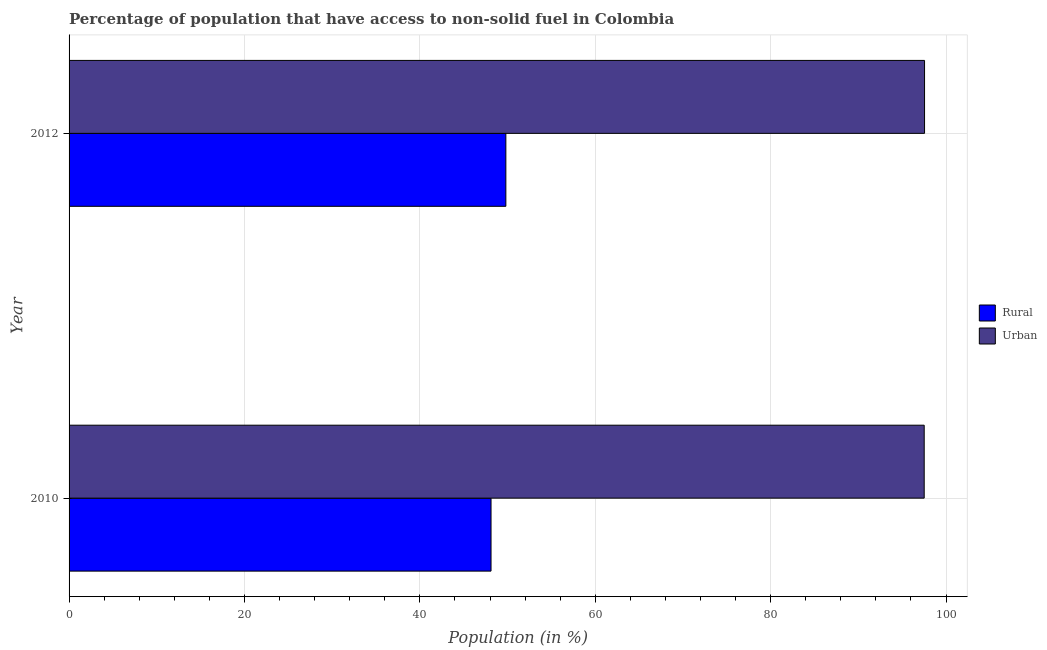How many different coloured bars are there?
Ensure brevity in your answer.  2. Are the number of bars per tick equal to the number of legend labels?
Offer a very short reply. Yes. How many bars are there on the 1st tick from the top?
Offer a terse response. 2. How many bars are there on the 2nd tick from the bottom?
Provide a succinct answer. 2. In how many cases, is the number of bars for a given year not equal to the number of legend labels?
Make the answer very short. 0. What is the urban population in 2010?
Offer a terse response. 97.51. Across all years, what is the maximum rural population?
Offer a very short reply. 49.81. Across all years, what is the minimum rural population?
Your answer should be compact. 48.11. In which year was the urban population minimum?
Provide a short and direct response. 2010. What is the total urban population in the graph?
Give a very brief answer. 195.06. What is the difference between the rural population in 2010 and that in 2012?
Your answer should be compact. -1.69. What is the difference between the rural population in 2010 and the urban population in 2012?
Ensure brevity in your answer.  -49.43. What is the average urban population per year?
Make the answer very short. 97.53. In the year 2012, what is the difference between the urban population and rural population?
Offer a terse response. 47.74. What is the ratio of the rural population in 2010 to that in 2012?
Ensure brevity in your answer.  0.97. In how many years, is the urban population greater than the average urban population taken over all years?
Your answer should be compact. 1. What does the 2nd bar from the top in 2010 represents?
Ensure brevity in your answer.  Rural. What does the 1st bar from the bottom in 2010 represents?
Make the answer very short. Rural. How many bars are there?
Ensure brevity in your answer.  4. Are all the bars in the graph horizontal?
Ensure brevity in your answer.  Yes. How many legend labels are there?
Your response must be concise. 2. How are the legend labels stacked?
Your response must be concise. Vertical. What is the title of the graph?
Ensure brevity in your answer.  Percentage of population that have access to non-solid fuel in Colombia. Does "Under-five" appear as one of the legend labels in the graph?
Offer a very short reply. No. What is the Population (in %) of Rural in 2010?
Provide a succinct answer. 48.11. What is the Population (in %) of Urban in 2010?
Ensure brevity in your answer.  97.51. What is the Population (in %) of Rural in 2012?
Your answer should be very brief. 49.81. What is the Population (in %) in Urban in 2012?
Provide a short and direct response. 97.55. Across all years, what is the maximum Population (in %) of Rural?
Provide a short and direct response. 49.81. Across all years, what is the maximum Population (in %) of Urban?
Your response must be concise. 97.55. Across all years, what is the minimum Population (in %) of Rural?
Make the answer very short. 48.11. Across all years, what is the minimum Population (in %) in Urban?
Make the answer very short. 97.51. What is the total Population (in %) of Rural in the graph?
Your answer should be very brief. 97.92. What is the total Population (in %) in Urban in the graph?
Ensure brevity in your answer.  195.06. What is the difference between the Population (in %) in Rural in 2010 and that in 2012?
Ensure brevity in your answer.  -1.69. What is the difference between the Population (in %) of Urban in 2010 and that in 2012?
Give a very brief answer. -0.04. What is the difference between the Population (in %) of Rural in 2010 and the Population (in %) of Urban in 2012?
Ensure brevity in your answer.  -49.43. What is the average Population (in %) in Rural per year?
Give a very brief answer. 48.96. What is the average Population (in %) of Urban per year?
Ensure brevity in your answer.  97.53. In the year 2010, what is the difference between the Population (in %) of Rural and Population (in %) of Urban?
Give a very brief answer. -49.39. In the year 2012, what is the difference between the Population (in %) of Rural and Population (in %) of Urban?
Provide a short and direct response. -47.74. What is the difference between the highest and the second highest Population (in %) in Rural?
Make the answer very short. 1.69. What is the difference between the highest and the second highest Population (in %) in Urban?
Keep it short and to the point. 0.04. What is the difference between the highest and the lowest Population (in %) in Rural?
Provide a succinct answer. 1.69. What is the difference between the highest and the lowest Population (in %) of Urban?
Your answer should be compact. 0.04. 